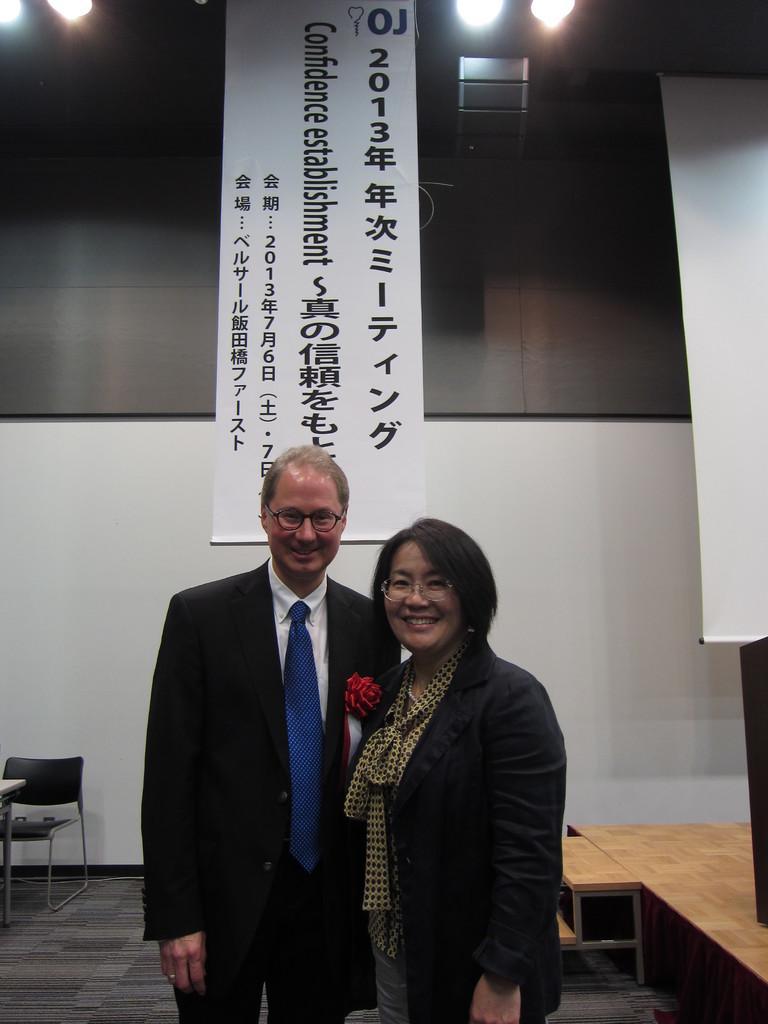Please provide a concise description of this image. In the image two people were standing and posing for the photo. Behind them there is a dais and in the background there is a wall and there is a banner attached in front of the wall and on the left side there is an empty chair. 